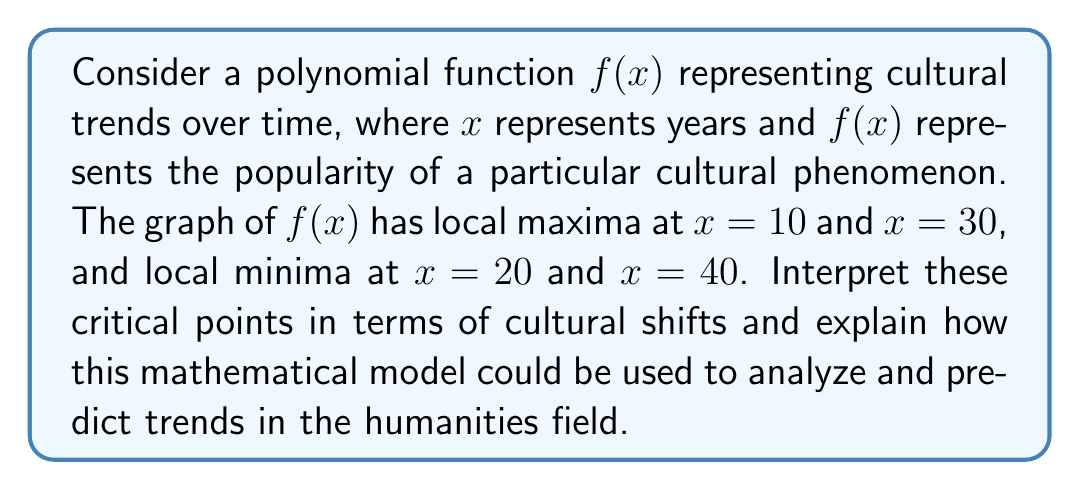Help me with this question. 1. Understand the representation:
   - $x$ axis: time (years)
   - $y$ axis: popularity of a cultural phenomenon
   - $f(x)$: function modeling the cultural trend

2. Interpret local maxima:
   - At $x=10$ and $x=30$, the function reaches local peaks
   - These represent periods of peak popularity or influence for the cultural phenomenon

3. Interpret local minima:
   - At $x=20$ and $x=40$, the function reaches local valleys
   - These represent periods of decreased popularity or influence

4. Analyze the pattern:
   - The alternating maxima and minima suggest cyclical nature of cultural trends
   - Each cycle lasts approximately 20 years (difference between consecutive maxima or minima)

5. Cultural shift interpretation:
   - Local maxima (years 10 and 30): Cultural renaissance or peak interest
   - Local minima (years 20 and 40): Cultural decline or shift in focus

6. Application to humanities:
   - Predict future trends based on observed cycles
   - Identify potential areas of renewed interest
   - Plan academic programs and research focus areas
   - Anticipate shifts in publishing trends and academic job markets

7. Limitations and considerations:
   - Real-world cultural trends may not follow exact polynomial patterns
   - External factors can influence trends unpredictably
   - Model should be regularly updated with new data

8. Interdisciplinary implications:
   - Combine mathematical modeling with cultural studies
   - Encourage data-driven approaches in humanities research
   - Foster collaboration between STEM and humanities fields
Answer: Local maxima represent peak popularity of cultural phenomena, while local minima indicate periods of decline or shift. This model can be used to predict cyclical trends in humanities, informing academic planning and research focus. 